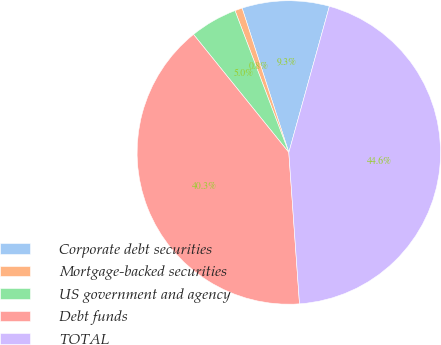Convert chart. <chart><loc_0><loc_0><loc_500><loc_500><pie_chart><fcel>Corporate debt securities<fcel>Mortgage-backed securities<fcel>US government and agency<fcel>Debt funds<fcel>TOTAL<nl><fcel>9.29%<fcel>0.79%<fcel>5.04%<fcel>40.31%<fcel>44.57%<nl></chart> 